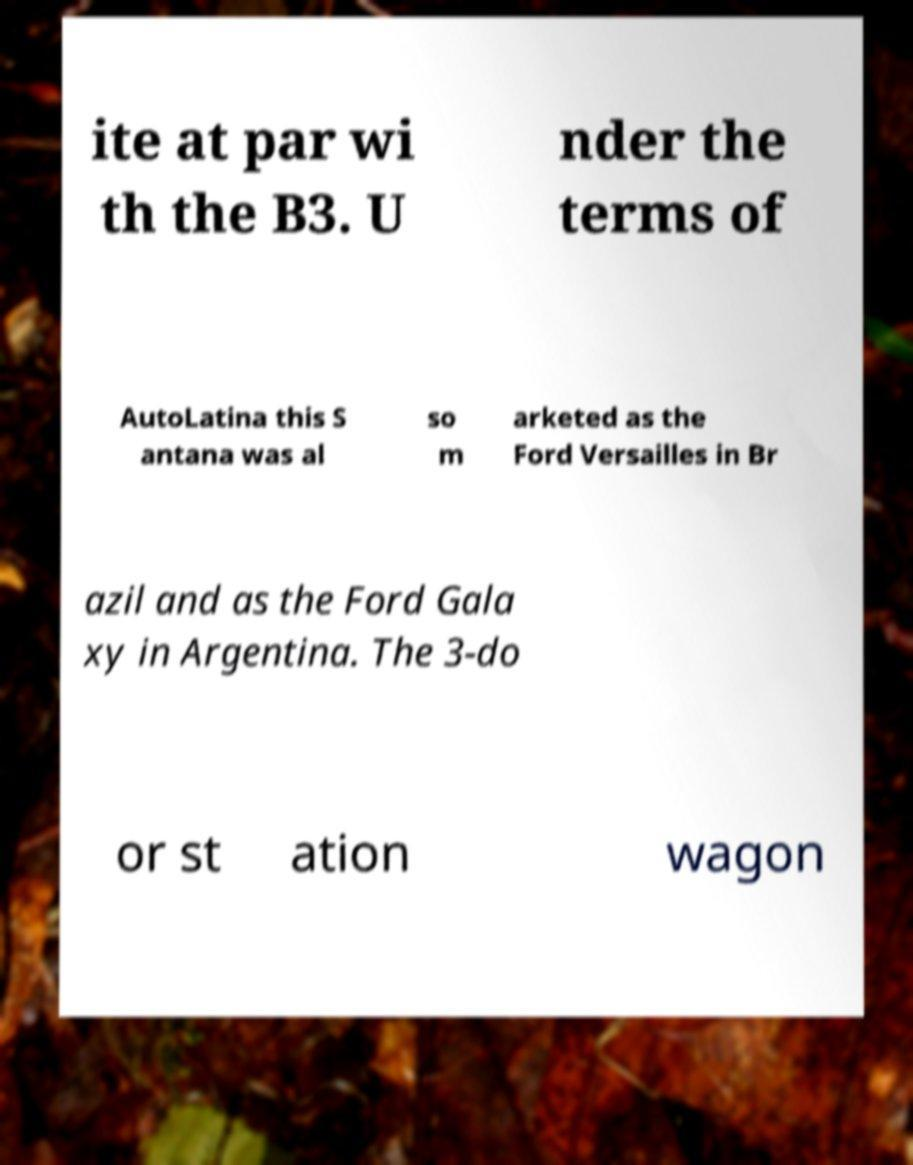What messages or text are displayed in this image? I need them in a readable, typed format. ite at par wi th the B3. U nder the terms of AutoLatina this S antana was al so m arketed as the Ford Versailles in Br azil and as the Ford Gala xy in Argentina. The 3-do or st ation wagon 